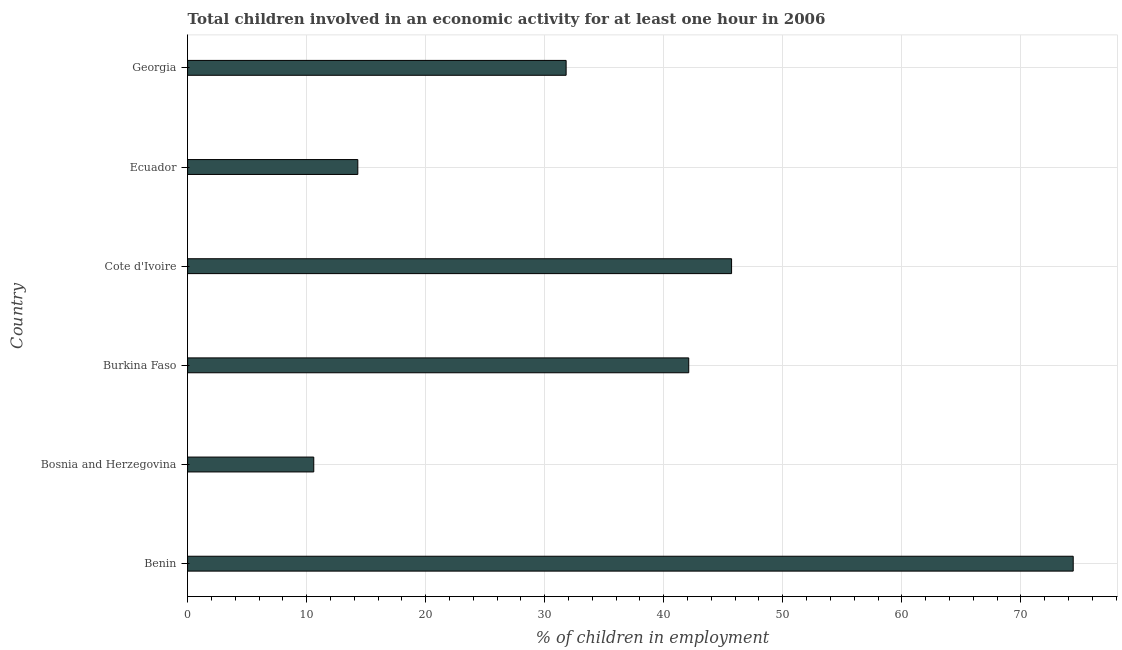Does the graph contain any zero values?
Offer a very short reply. No. What is the title of the graph?
Offer a very short reply. Total children involved in an economic activity for at least one hour in 2006. What is the label or title of the X-axis?
Provide a short and direct response. % of children in employment. What is the label or title of the Y-axis?
Offer a very short reply. Country. What is the percentage of children in employment in Benin?
Give a very brief answer. 74.4. Across all countries, what is the maximum percentage of children in employment?
Offer a terse response. 74.4. Across all countries, what is the minimum percentage of children in employment?
Make the answer very short. 10.6. In which country was the percentage of children in employment maximum?
Provide a succinct answer. Benin. In which country was the percentage of children in employment minimum?
Ensure brevity in your answer.  Bosnia and Herzegovina. What is the sum of the percentage of children in employment?
Your answer should be compact. 218.9. What is the difference between the percentage of children in employment in Benin and Georgia?
Your response must be concise. 42.6. What is the average percentage of children in employment per country?
Provide a short and direct response. 36.48. What is the median percentage of children in employment?
Provide a succinct answer. 36.95. What is the ratio of the percentage of children in employment in Benin to that in Burkina Faso?
Offer a terse response. 1.77. Is the percentage of children in employment in Benin less than that in Georgia?
Provide a succinct answer. No. Is the difference between the percentage of children in employment in Bosnia and Herzegovina and Georgia greater than the difference between any two countries?
Provide a succinct answer. No. What is the difference between the highest and the second highest percentage of children in employment?
Provide a succinct answer. 28.7. What is the difference between the highest and the lowest percentage of children in employment?
Your answer should be compact. 63.8. In how many countries, is the percentage of children in employment greater than the average percentage of children in employment taken over all countries?
Your answer should be very brief. 3. Are all the bars in the graph horizontal?
Your response must be concise. Yes. What is the % of children in employment in Benin?
Your answer should be compact. 74.4. What is the % of children in employment in Burkina Faso?
Your response must be concise. 42.1. What is the % of children in employment of Cote d'Ivoire?
Your response must be concise. 45.7. What is the % of children in employment in Georgia?
Ensure brevity in your answer.  31.8. What is the difference between the % of children in employment in Benin and Bosnia and Herzegovina?
Provide a short and direct response. 63.8. What is the difference between the % of children in employment in Benin and Burkina Faso?
Keep it short and to the point. 32.3. What is the difference between the % of children in employment in Benin and Cote d'Ivoire?
Keep it short and to the point. 28.7. What is the difference between the % of children in employment in Benin and Ecuador?
Your answer should be compact. 60.1. What is the difference between the % of children in employment in Benin and Georgia?
Provide a short and direct response. 42.6. What is the difference between the % of children in employment in Bosnia and Herzegovina and Burkina Faso?
Provide a succinct answer. -31.5. What is the difference between the % of children in employment in Bosnia and Herzegovina and Cote d'Ivoire?
Keep it short and to the point. -35.1. What is the difference between the % of children in employment in Bosnia and Herzegovina and Georgia?
Provide a short and direct response. -21.2. What is the difference between the % of children in employment in Burkina Faso and Ecuador?
Offer a terse response. 27.8. What is the difference between the % of children in employment in Cote d'Ivoire and Ecuador?
Your answer should be very brief. 31.4. What is the difference between the % of children in employment in Ecuador and Georgia?
Make the answer very short. -17.5. What is the ratio of the % of children in employment in Benin to that in Bosnia and Herzegovina?
Keep it short and to the point. 7.02. What is the ratio of the % of children in employment in Benin to that in Burkina Faso?
Give a very brief answer. 1.77. What is the ratio of the % of children in employment in Benin to that in Cote d'Ivoire?
Your response must be concise. 1.63. What is the ratio of the % of children in employment in Benin to that in Ecuador?
Your response must be concise. 5.2. What is the ratio of the % of children in employment in Benin to that in Georgia?
Keep it short and to the point. 2.34. What is the ratio of the % of children in employment in Bosnia and Herzegovina to that in Burkina Faso?
Your answer should be very brief. 0.25. What is the ratio of the % of children in employment in Bosnia and Herzegovina to that in Cote d'Ivoire?
Your response must be concise. 0.23. What is the ratio of the % of children in employment in Bosnia and Herzegovina to that in Ecuador?
Your answer should be compact. 0.74. What is the ratio of the % of children in employment in Bosnia and Herzegovina to that in Georgia?
Offer a terse response. 0.33. What is the ratio of the % of children in employment in Burkina Faso to that in Cote d'Ivoire?
Ensure brevity in your answer.  0.92. What is the ratio of the % of children in employment in Burkina Faso to that in Ecuador?
Provide a succinct answer. 2.94. What is the ratio of the % of children in employment in Burkina Faso to that in Georgia?
Your answer should be compact. 1.32. What is the ratio of the % of children in employment in Cote d'Ivoire to that in Ecuador?
Give a very brief answer. 3.2. What is the ratio of the % of children in employment in Cote d'Ivoire to that in Georgia?
Provide a succinct answer. 1.44. What is the ratio of the % of children in employment in Ecuador to that in Georgia?
Provide a succinct answer. 0.45. 